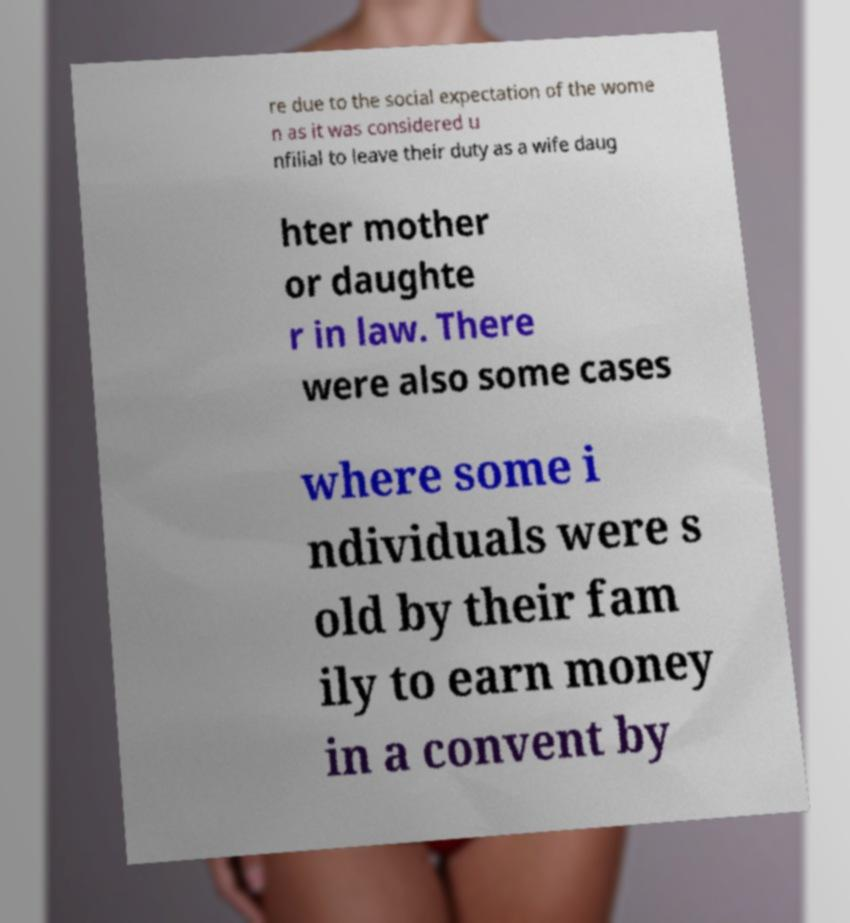Please read and relay the text visible in this image. What does it say? re due to the social expectation of the wome n as it was considered u nfilial to leave their duty as a wife daug hter mother or daughte r in law. There were also some cases where some i ndividuals were s old by their fam ily to earn money in a convent by 